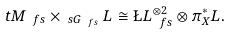<formula> <loc_0><loc_0><loc_500><loc_500>\ t M _ { \ f s } \times _ { \ s G _ { \ f s } } L \cong \L L _ { \ f s } ^ { \otimes 2 } \otimes \pi _ { X } ^ { * } L .</formula> 